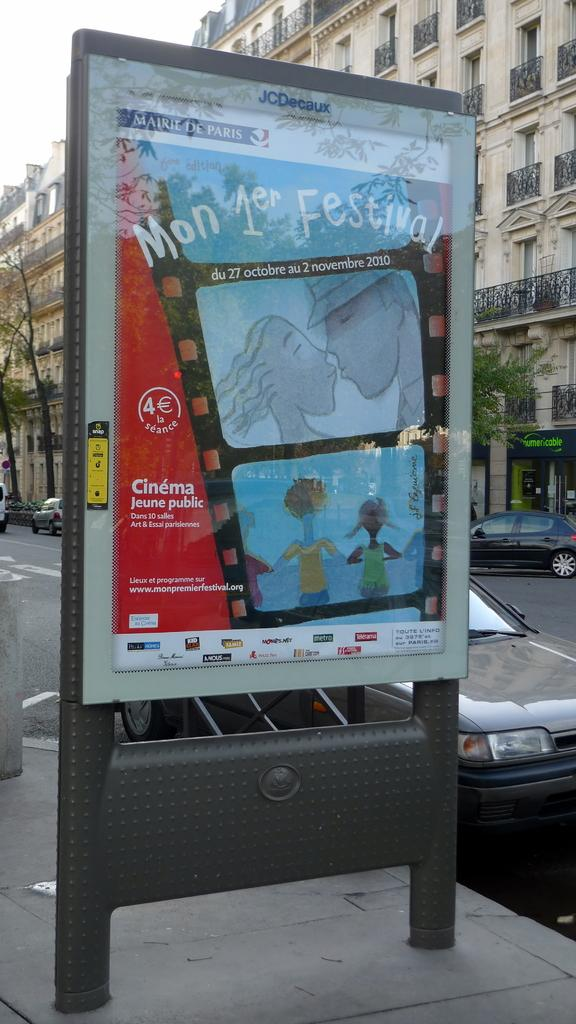<image>
Relay a brief, clear account of the picture shown. An advertisement for a festival on a city sidewalk. 